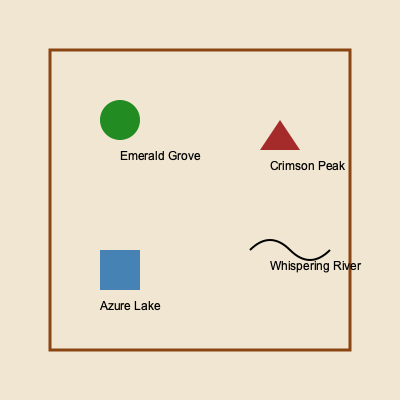In this fictional map of Eldoria, which landmark is represented by a polygon and likely represents the highest point in the region? To answer this question, we need to analyze the different symbols on the map and their potential meanings:

1. Circle (green): This symbol is labeled "Emerald Grove," likely representing a forested area.
2. Polygon (brown triangle): This symbol is labeled "Crimson Peak," suggesting a mountain or high point.
3. Square (blue): This symbol is labeled "Azure Lake," indicating a body of water.
4. Curved line: This symbol is labeled "Whispering River," representing a river.

Among these landmarks, a peak or mountain would typically be the highest point in a region. The polygon shape (triangle) is a common cartographic symbol for mountains or peaks.

The brown color of the polygon could also represent the earthy tones of a mountain or rocky terrain.

The name "Crimson Peak" further supports this interpretation, as "peak" is often used to describe the summit of a mountain.

Therefore, the landmark represented by a polygon and likely representing the highest point in the region is Crimson Peak.
Answer: Crimson Peak 